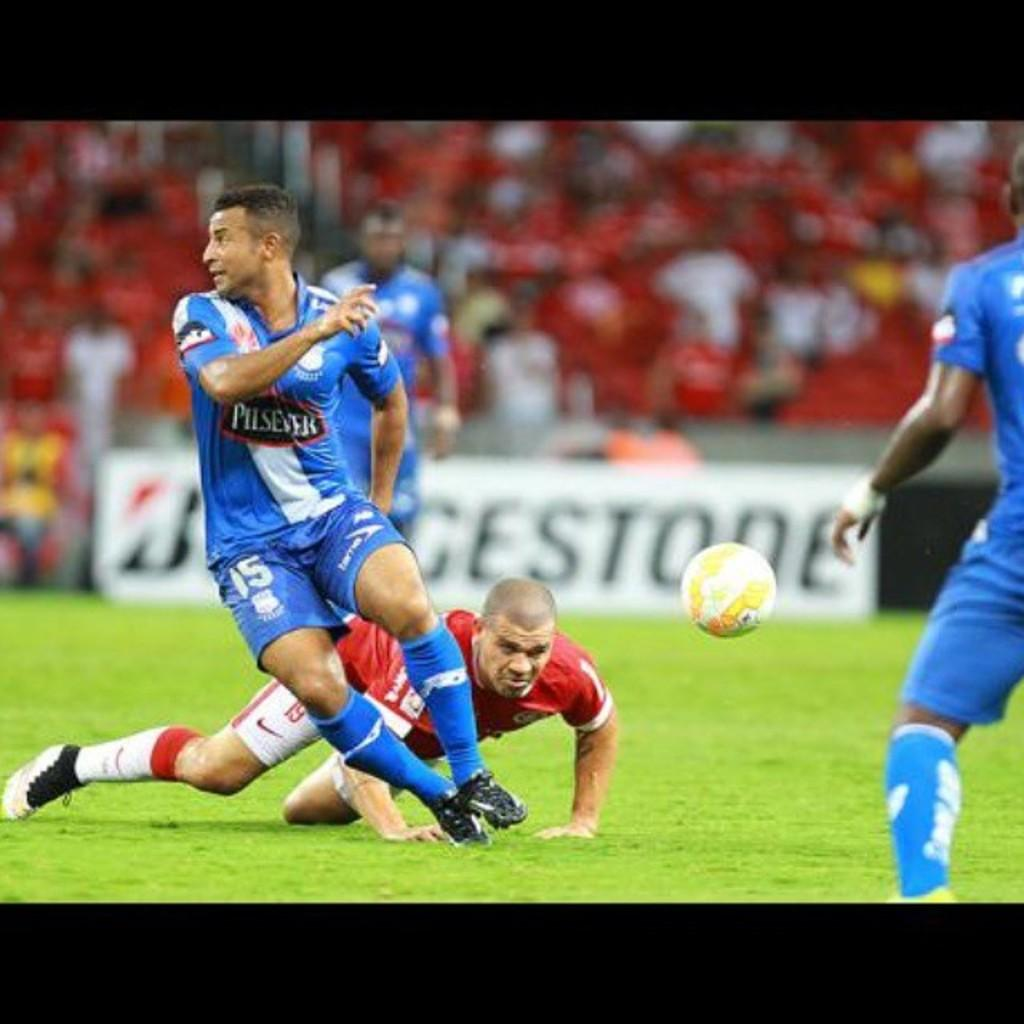<image>
Provide a brief description of the given image. Two soccer players are vying for the ball with the logo for bridgeston in the background. 